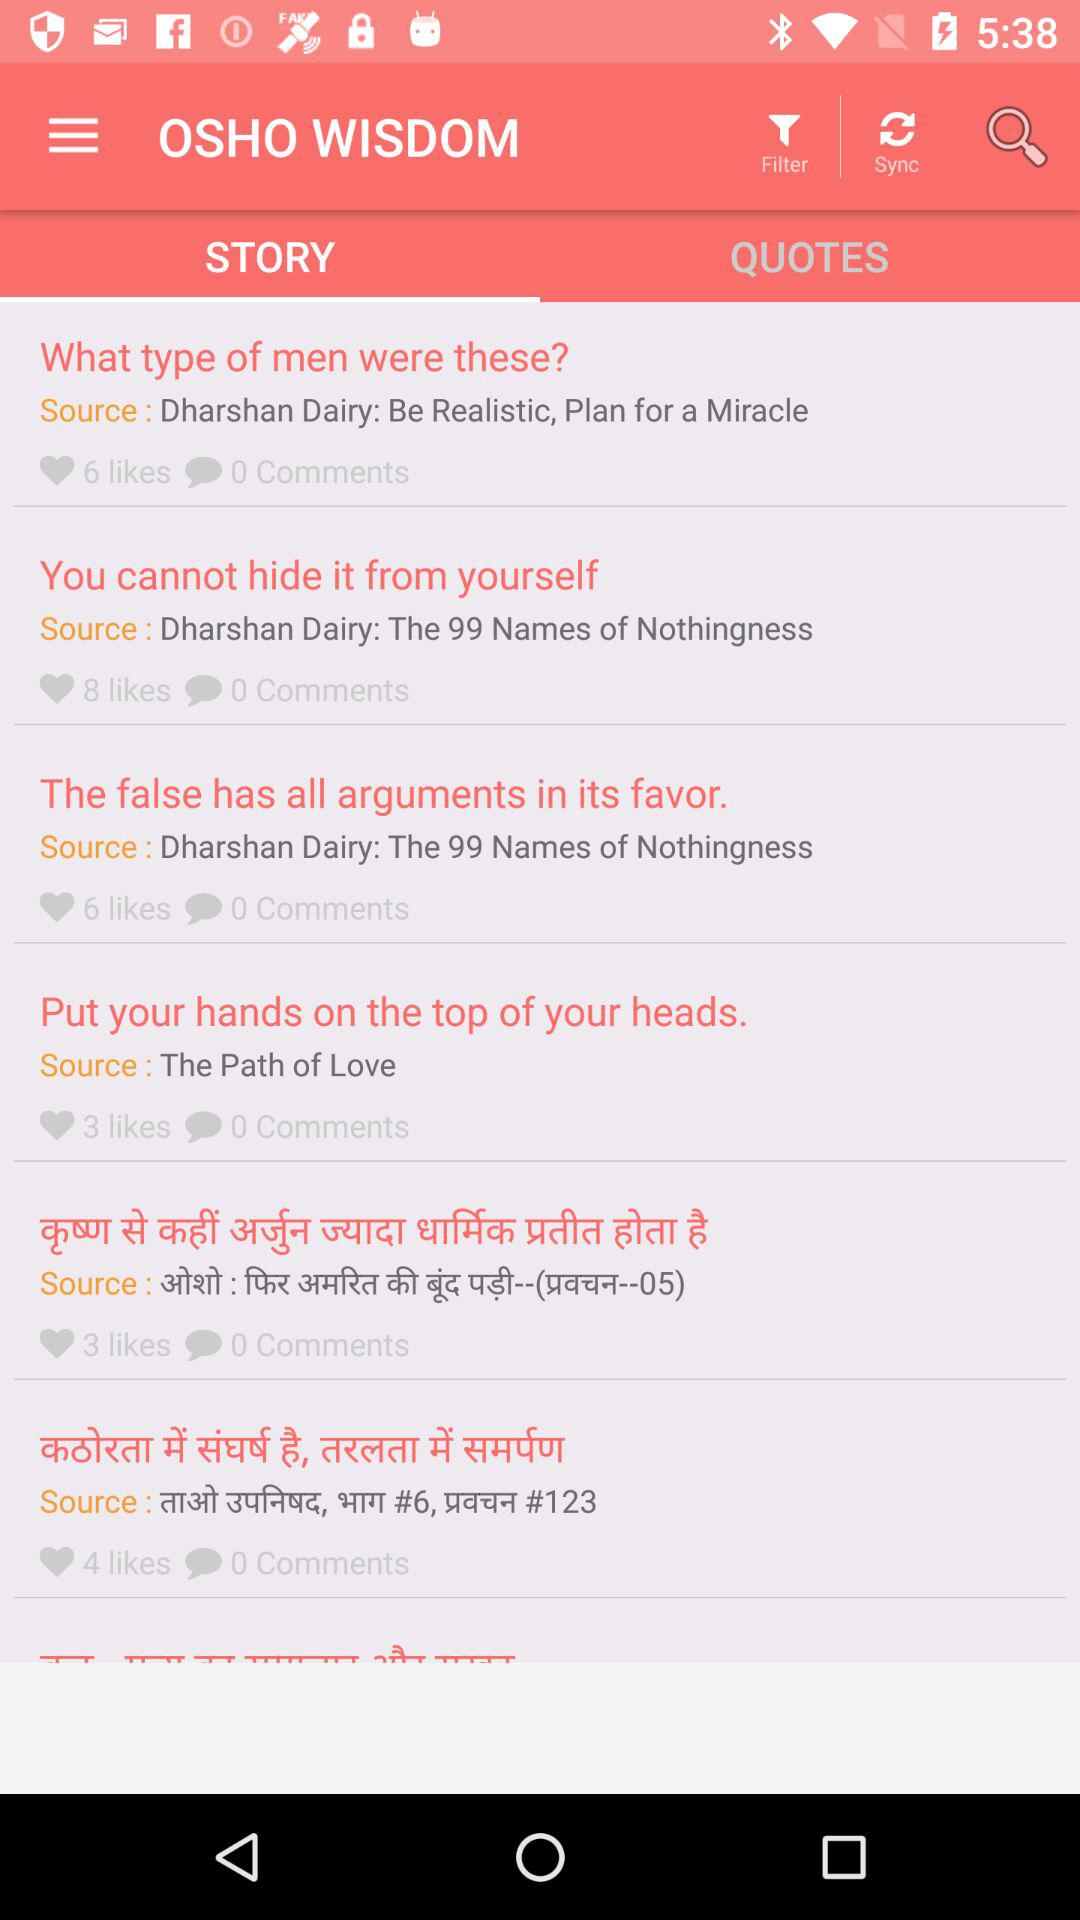How many likes does the first item have?
Answer the question using a single word or phrase. 6 